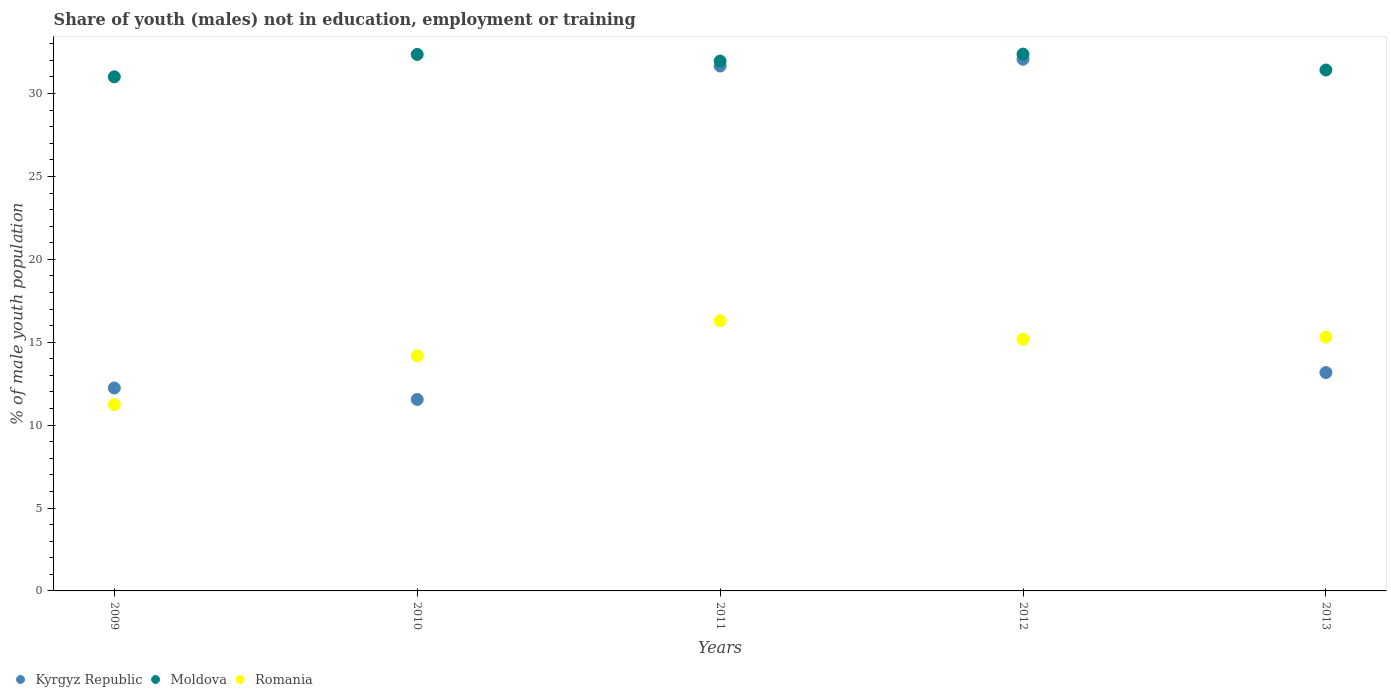What is the percentage of unemployed males population in in Romania in 2009?
Provide a succinct answer. 11.24. Across all years, what is the maximum percentage of unemployed males population in in Kyrgyz Republic?
Give a very brief answer. 32.07. Across all years, what is the minimum percentage of unemployed males population in in Romania?
Ensure brevity in your answer.  11.24. In which year was the percentage of unemployed males population in in Moldova maximum?
Your response must be concise. 2012. In which year was the percentage of unemployed males population in in Romania minimum?
Make the answer very short. 2009. What is the total percentage of unemployed males population in in Romania in the graph?
Your answer should be very brief. 72.21. What is the difference between the percentage of unemployed males population in in Moldova in 2012 and that in 2013?
Offer a very short reply. 0.96. What is the difference between the percentage of unemployed males population in in Moldova in 2011 and the percentage of unemployed males population in in Kyrgyz Republic in 2012?
Offer a terse response. -0.11. What is the average percentage of unemployed males population in in Romania per year?
Your answer should be very brief. 14.44. In the year 2013, what is the difference between the percentage of unemployed males population in in Romania and percentage of unemployed males population in in Kyrgyz Republic?
Provide a succinct answer. 2.14. What is the ratio of the percentage of unemployed males population in in Kyrgyz Republic in 2011 to that in 2012?
Ensure brevity in your answer.  0.99. What is the difference between the highest and the second highest percentage of unemployed males population in in Kyrgyz Republic?
Your answer should be very brief. 0.41. What is the difference between the highest and the lowest percentage of unemployed males population in in Kyrgyz Republic?
Your answer should be compact. 20.52. In how many years, is the percentage of unemployed males population in in Moldova greater than the average percentage of unemployed males population in in Moldova taken over all years?
Offer a terse response. 3. Does the percentage of unemployed males population in in Romania monotonically increase over the years?
Ensure brevity in your answer.  No. What is the difference between two consecutive major ticks on the Y-axis?
Your response must be concise. 5. Does the graph contain any zero values?
Your response must be concise. No. Does the graph contain grids?
Make the answer very short. No. How are the legend labels stacked?
Make the answer very short. Horizontal. What is the title of the graph?
Your answer should be very brief. Share of youth (males) not in education, employment or training. What is the label or title of the Y-axis?
Offer a terse response. % of male youth population. What is the % of male youth population of Kyrgyz Republic in 2009?
Keep it short and to the point. 12.24. What is the % of male youth population of Moldova in 2009?
Ensure brevity in your answer.  31.01. What is the % of male youth population of Romania in 2009?
Provide a succinct answer. 11.24. What is the % of male youth population of Kyrgyz Republic in 2010?
Your answer should be very brief. 11.55. What is the % of male youth population in Moldova in 2010?
Your answer should be very brief. 32.36. What is the % of male youth population of Romania in 2010?
Provide a succinct answer. 14.18. What is the % of male youth population of Kyrgyz Republic in 2011?
Your answer should be very brief. 31.66. What is the % of male youth population of Moldova in 2011?
Your response must be concise. 31.96. What is the % of male youth population in Romania in 2011?
Keep it short and to the point. 16.3. What is the % of male youth population in Kyrgyz Republic in 2012?
Offer a very short reply. 32.07. What is the % of male youth population of Moldova in 2012?
Offer a terse response. 32.38. What is the % of male youth population in Romania in 2012?
Your response must be concise. 15.18. What is the % of male youth population in Kyrgyz Republic in 2013?
Provide a short and direct response. 13.17. What is the % of male youth population in Moldova in 2013?
Your answer should be compact. 31.42. What is the % of male youth population in Romania in 2013?
Your answer should be compact. 15.31. Across all years, what is the maximum % of male youth population of Kyrgyz Republic?
Your answer should be very brief. 32.07. Across all years, what is the maximum % of male youth population in Moldova?
Your answer should be very brief. 32.38. Across all years, what is the maximum % of male youth population in Romania?
Make the answer very short. 16.3. Across all years, what is the minimum % of male youth population in Kyrgyz Republic?
Your answer should be very brief. 11.55. Across all years, what is the minimum % of male youth population in Moldova?
Your answer should be compact. 31.01. Across all years, what is the minimum % of male youth population in Romania?
Ensure brevity in your answer.  11.24. What is the total % of male youth population in Kyrgyz Republic in the graph?
Your response must be concise. 100.69. What is the total % of male youth population of Moldova in the graph?
Your answer should be very brief. 159.13. What is the total % of male youth population of Romania in the graph?
Make the answer very short. 72.21. What is the difference between the % of male youth population in Kyrgyz Republic in 2009 and that in 2010?
Your answer should be compact. 0.69. What is the difference between the % of male youth population of Moldova in 2009 and that in 2010?
Provide a short and direct response. -1.35. What is the difference between the % of male youth population of Romania in 2009 and that in 2010?
Give a very brief answer. -2.94. What is the difference between the % of male youth population in Kyrgyz Republic in 2009 and that in 2011?
Provide a short and direct response. -19.42. What is the difference between the % of male youth population in Moldova in 2009 and that in 2011?
Give a very brief answer. -0.95. What is the difference between the % of male youth population in Romania in 2009 and that in 2011?
Make the answer very short. -5.06. What is the difference between the % of male youth population in Kyrgyz Republic in 2009 and that in 2012?
Provide a short and direct response. -19.83. What is the difference between the % of male youth population in Moldova in 2009 and that in 2012?
Provide a succinct answer. -1.37. What is the difference between the % of male youth population of Romania in 2009 and that in 2012?
Keep it short and to the point. -3.94. What is the difference between the % of male youth population in Kyrgyz Republic in 2009 and that in 2013?
Provide a short and direct response. -0.93. What is the difference between the % of male youth population of Moldova in 2009 and that in 2013?
Ensure brevity in your answer.  -0.41. What is the difference between the % of male youth population in Romania in 2009 and that in 2013?
Give a very brief answer. -4.07. What is the difference between the % of male youth population of Kyrgyz Republic in 2010 and that in 2011?
Provide a short and direct response. -20.11. What is the difference between the % of male youth population of Moldova in 2010 and that in 2011?
Offer a very short reply. 0.4. What is the difference between the % of male youth population of Romania in 2010 and that in 2011?
Ensure brevity in your answer.  -2.12. What is the difference between the % of male youth population in Kyrgyz Republic in 2010 and that in 2012?
Provide a succinct answer. -20.52. What is the difference between the % of male youth population of Moldova in 2010 and that in 2012?
Provide a succinct answer. -0.02. What is the difference between the % of male youth population in Kyrgyz Republic in 2010 and that in 2013?
Your response must be concise. -1.62. What is the difference between the % of male youth population of Moldova in 2010 and that in 2013?
Offer a very short reply. 0.94. What is the difference between the % of male youth population in Romania in 2010 and that in 2013?
Keep it short and to the point. -1.13. What is the difference between the % of male youth population of Kyrgyz Republic in 2011 and that in 2012?
Offer a very short reply. -0.41. What is the difference between the % of male youth population in Moldova in 2011 and that in 2012?
Your response must be concise. -0.42. What is the difference between the % of male youth population of Romania in 2011 and that in 2012?
Provide a succinct answer. 1.12. What is the difference between the % of male youth population of Kyrgyz Republic in 2011 and that in 2013?
Your answer should be compact. 18.49. What is the difference between the % of male youth population in Moldova in 2011 and that in 2013?
Keep it short and to the point. 0.54. What is the difference between the % of male youth population of Romania in 2012 and that in 2013?
Keep it short and to the point. -0.13. What is the difference between the % of male youth population in Kyrgyz Republic in 2009 and the % of male youth population in Moldova in 2010?
Give a very brief answer. -20.12. What is the difference between the % of male youth population in Kyrgyz Republic in 2009 and the % of male youth population in Romania in 2010?
Make the answer very short. -1.94. What is the difference between the % of male youth population in Moldova in 2009 and the % of male youth population in Romania in 2010?
Your answer should be very brief. 16.83. What is the difference between the % of male youth population in Kyrgyz Republic in 2009 and the % of male youth population in Moldova in 2011?
Your answer should be very brief. -19.72. What is the difference between the % of male youth population in Kyrgyz Republic in 2009 and the % of male youth population in Romania in 2011?
Offer a very short reply. -4.06. What is the difference between the % of male youth population in Moldova in 2009 and the % of male youth population in Romania in 2011?
Your answer should be very brief. 14.71. What is the difference between the % of male youth population in Kyrgyz Republic in 2009 and the % of male youth population in Moldova in 2012?
Offer a very short reply. -20.14. What is the difference between the % of male youth population of Kyrgyz Republic in 2009 and the % of male youth population of Romania in 2012?
Your response must be concise. -2.94. What is the difference between the % of male youth population of Moldova in 2009 and the % of male youth population of Romania in 2012?
Your answer should be compact. 15.83. What is the difference between the % of male youth population of Kyrgyz Republic in 2009 and the % of male youth population of Moldova in 2013?
Offer a terse response. -19.18. What is the difference between the % of male youth population in Kyrgyz Republic in 2009 and the % of male youth population in Romania in 2013?
Your response must be concise. -3.07. What is the difference between the % of male youth population of Moldova in 2009 and the % of male youth population of Romania in 2013?
Give a very brief answer. 15.7. What is the difference between the % of male youth population in Kyrgyz Republic in 2010 and the % of male youth population in Moldova in 2011?
Give a very brief answer. -20.41. What is the difference between the % of male youth population of Kyrgyz Republic in 2010 and the % of male youth population of Romania in 2011?
Give a very brief answer. -4.75. What is the difference between the % of male youth population in Moldova in 2010 and the % of male youth population in Romania in 2011?
Keep it short and to the point. 16.06. What is the difference between the % of male youth population of Kyrgyz Republic in 2010 and the % of male youth population of Moldova in 2012?
Provide a succinct answer. -20.83. What is the difference between the % of male youth population of Kyrgyz Republic in 2010 and the % of male youth population of Romania in 2012?
Provide a short and direct response. -3.63. What is the difference between the % of male youth population in Moldova in 2010 and the % of male youth population in Romania in 2012?
Make the answer very short. 17.18. What is the difference between the % of male youth population in Kyrgyz Republic in 2010 and the % of male youth population in Moldova in 2013?
Your answer should be compact. -19.87. What is the difference between the % of male youth population of Kyrgyz Republic in 2010 and the % of male youth population of Romania in 2013?
Make the answer very short. -3.76. What is the difference between the % of male youth population of Moldova in 2010 and the % of male youth population of Romania in 2013?
Keep it short and to the point. 17.05. What is the difference between the % of male youth population of Kyrgyz Republic in 2011 and the % of male youth population of Moldova in 2012?
Give a very brief answer. -0.72. What is the difference between the % of male youth population in Kyrgyz Republic in 2011 and the % of male youth population in Romania in 2012?
Give a very brief answer. 16.48. What is the difference between the % of male youth population in Moldova in 2011 and the % of male youth population in Romania in 2012?
Ensure brevity in your answer.  16.78. What is the difference between the % of male youth population of Kyrgyz Republic in 2011 and the % of male youth population of Moldova in 2013?
Your answer should be very brief. 0.24. What is the difference between the % of male youth population in Kyrgyz Republic in 2011 and the % of male youth population in Romania in 2013?
Offer a very short reply. 16.35. What is the difference between the % of male youth population in Moldova in 2011 and the % of male youth population in Romania in 2013?
Offer a very short reply. 16.65. What is the difference between the % of male youth population in Kyrgyz Republic in 2012 and the % of male youth population in Moldova in 2013?
Make the answer very short. 0.65. What is the difference between the % of male youth population in Kyrgyz Republic in 2012 and the % of male youth population in Romania in 2013?
Ensure brevity in your answer.  16.76. What is the difference between the % of male youth population of Moldova in 2012 and the % of male youth population of Romania in 2013?
Your response must be concise. 17.07. What is the average % of male youth population of Kyrgyz Republic per year?
Keep it short and to the point. 20.14. What is the average % of male youth population in Moldova per year?
Ensure brevity in your answer.  31.83. What is the average % of male youth population of Romania per year?
Offer a very short reply. 14.44. In the year 2009, what is the difference between the % of male youth population in Kyrgyz Republic and % of male youth population in Moldova?
Your answer should be very brief. -18.77. In the year 2009, what is the difference between the % of male youth population in Moldova and % of male youth population in Romania?
Your answer should be compact. 19.77. In the year 2010, what is the difference between the % of male youth population in Kyrgyz Republic and % of male youth population in Moldova?
Make the answer very short. -20.81. In the year 2010, what is the difference between the % of male youth population of Kyrgyz Republic and % of male youth population of Romania?
Make the answer very short. -2.63. In the year 2010, what is the difference between the % of male youth population in Moldova and % of male youth population in Romania?
Keep it short and to the point. 18.18. In the year 2011, what is the difference between the % of male youth population of Kyrgyz Republic and % of male youth population of Romania?
Make the answer very short. 15.36. In the year 2011, what is the difference between the % of male youth population in Moldova and % of male youth population in Romania?
Provide a succinct answer. 15.66. In the year 2012, what is the difference between the % of male youth population in Kyrgyz Republic and % of male youth population in Moldova?
Ensure brevity in your answer.  -0.31. In the year 2012, what is the difference between the % of male youth population of Kyrgyz Republic and % of male youth population of Romania?
Make the answer very short. 16.89. In the year 2012, what is the difference between the % of male youth population of Moldova and % of male youth population of Romania?
Your answer should be compact. 17.2. In the year 2013, what is the difference between the % of male youth population of Kyrgyz Republic and % of male youth population of Moldova?
Make the answer very short. -18.25. In the year 2013, what is the difference between the % of male youth population of Kyrgyz Republic and % of male youth population of Romania?
Make the answer very short. -2.14. In the year 2013, what is the difference between the % of male youth population in Moldova and % of male youth population in Romania?
Make the answer very short. 16.11. What is the ratio of the % of male youth population of Kyrgyz Republic in 2009 to that in 2010?
Ensure brevity in your answer.  1.06. What is the ratio of the % of male youth population of Moldova in 2009 to that in 2010?
Give a very brief answer. 0.96. What is the ratio of the % of male youth population in Romania in 2009 to that in 2010?
Give a very brief answer. 0.79. What is the ratio of the % of male youth population of Kyrgyz Republic in 2009 to that in 2011?
Give a very brief answer. 0.39. What is the ratio of the % of male youth population of Moldova in 2009 to that in 2011?
Ensure brevity in your answer.  0.97. What is the ratio of the % of male youth population in Romania in 2009 to that in 2011?
Your answer should be very brief. 0.69. What is the ratio of the % of male youth population in Kyrgyz Republic in 2009 to that in 2012?
Provide a succinct answer. 0.38. What is the ratio of the % of male youth population in Moldova in 2009 to that in 2012?
Your response must be concise. 0.96. What is the ratio of the % of male youth population of Romania in 2009 to that in 2012?
Give a very brief answer. 0.74. What is the ratio of the % of male youth population in Kyrgyz Republic in 2009 to that in 2013?
Your answer should be compact. 0.93. What is the ratio of the % of male youth population in Romania in 2009 to that in 2013?
Ensure brevity in your answer.  0.73. What is the ratio of the % of male youth population in Kyrgyz Republic in 2010 to that in 2011?
Offer a terse response. 0.36. What is the ratio of the % of male youth population in Moldova in 2010 to that in 2011?
Your answer should be very brief. 1.01. What is the ratio of the % of male youth population in Romania in 2010 to that in 2011?
Give a very brief answer. 0.87. What is the ratio of the % of male youth population in Kyrgyz Republic in 2010 to that in 2012?
Provide a short and direct response. 0.36. What is the ratio of the % of male youth population of Moldova in 2010 to that in 2012?
Your response must be concise. 1. What is the ratio of the % of male youth population of Romania in 2010 to that in 2012?
Offer a very short reply. 0.93. What is the ratio of the % of male youth population in Kyrgyz Republic in 2010 to that in 2013?
Keep it short and to the point. 0.88. What is the ratio of the % of male youth population in Moldova in 2010 to that in 2013?
Provide a succinct answer. 1.03. What is the ratio of the % of male youth population in Romania in 2010 to that in 2013?
Offer a terse response. 0.93. What is the ratio of the % of male youth population of Kyrgyz Republic in 2011 to that in 2012?
Make the answer very short. 0.99. What is the ratio of the % of male youth population in Moldova in 2011 to that in 2012?
Provide a short and direct response. 0.99. What is the ratio of the % of male youth population of Romania in 2011 to that in 2012?
Ensure brevity in your answer.  1.07. What is the ratio of the % of male youth population of Kyrgyz Republic in 2011 to that in 2013?
Offer a terse response. 2.4. What is the ratio of the % of male youth population of Moldova in 2011 to that in 2013?
Keep it short and to the point. 1.02. What is the ratio of the % of male youth population in Romania in 2011 to that in 2013?
Give a very brief answer. 1.06. What is the ratio of the % of male youth population of Kyrgyz Republic in 2012 to that in 2013?
Give a very brief answer. 2.44. What is the ratio of the % of male youth population in Moldova in 2012 to that in 2013?
Your answer should be very brief. 1.03. What is the difference between the highest and the second highest % of male youth population in Kyrgyz Republic?
Make the answer very short. 0.41. What is the difference between the highest and the second highest % of male youth population in Romania?
Your response must be concise. 0.99. What is the difference between the highest and the lowest % of male youth population of Kyrgyz Republic?
Offer a terse response. 20.52. What is the difference between the highest and the lowest % of male youth population in Moldova?
Your answer should be compact. 1.37. What is the difference between the highest and the lowest % of male youth population in Romania?
Provide a succinct answer. 5.06. 